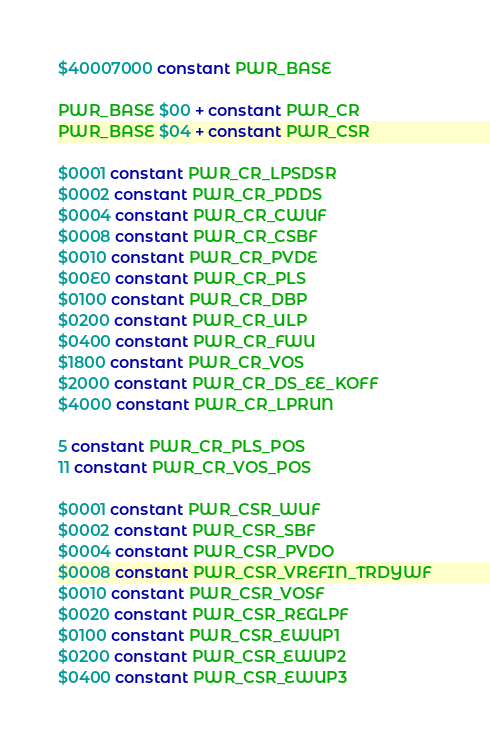<code> <loc_0><loc_0><loc_500><loc_500><_Forth_>$40007000 constant PWR_BASE

PWR_BASE $00 + constant PWR_CR
PWR_BASE $04 + constant PWR_CSR

$0001 constant PWR_CR_LPSDSR
$0002 constant PWR_CR_PDDS
$0004 constant PWR_CR_CWUF
$0008 constant PWR_CR_CSBF
$0010 constant PWR_CR_PVDE
$00E0 constant PWR_CR_PLS
$0100 constant PWR_CR_DBP
$0200 constant PWR_CR_ULP
$0400 constant PWR_CR_FWU
$1800 constant PWR_CR_VOS
$2000 constant PWR_CR_DS_EE_KOFF
$4000 constant PWR_CR_LPRUN

5 constant PWR_CR_PLS_POS
11 constant PWR_CR_VOS_POS

$0001 constant PWR_CSR_WUF
$0002 constant PWR_CSR_SBF
$0004 constant PWR_CSR_PVDO
$0008 constant PWR_CSR_VREFIN_TRDYWF
$0010 constant PWR_CSR_VOSF
$0020 constant PWR_CSR_REGLPF
$0100 constant PWR_CSR_EWUP1
$0200 constant PWR_CSR_EWUP2
$0400 constant PWR_CSR_EWUP3
</code> 